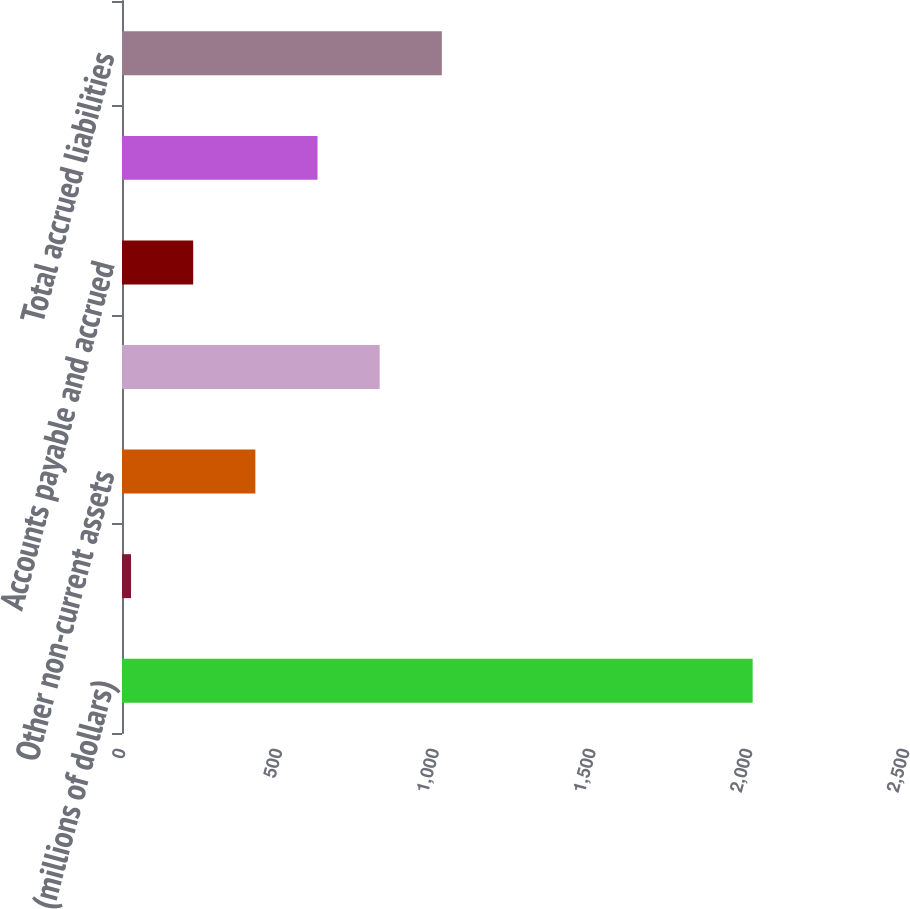Convert chart. <chart><loc_0><loc_0><loc_500><loc_500><bar_chart><fcel>(millions of dollars)<fcel>Prepayments and other current<fcel>Other non-current assets<fcel>Total insurance assets<fcel>Accounts payable and accrued<fcel>Other non-current liabilities<fcel>Total accrued liabilities<nl><fcel>2011<fcel>28.8<fcel>425.24<fcel>821.68<fcel>227.02<fcel>623.46<fcel>1019.9<nl></chart> 